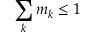Convert formula to latex. <formula><loc_0><loc_0><loc_500><loc_500>\sum _ { k } m _ { k } \leq 1</formula> 